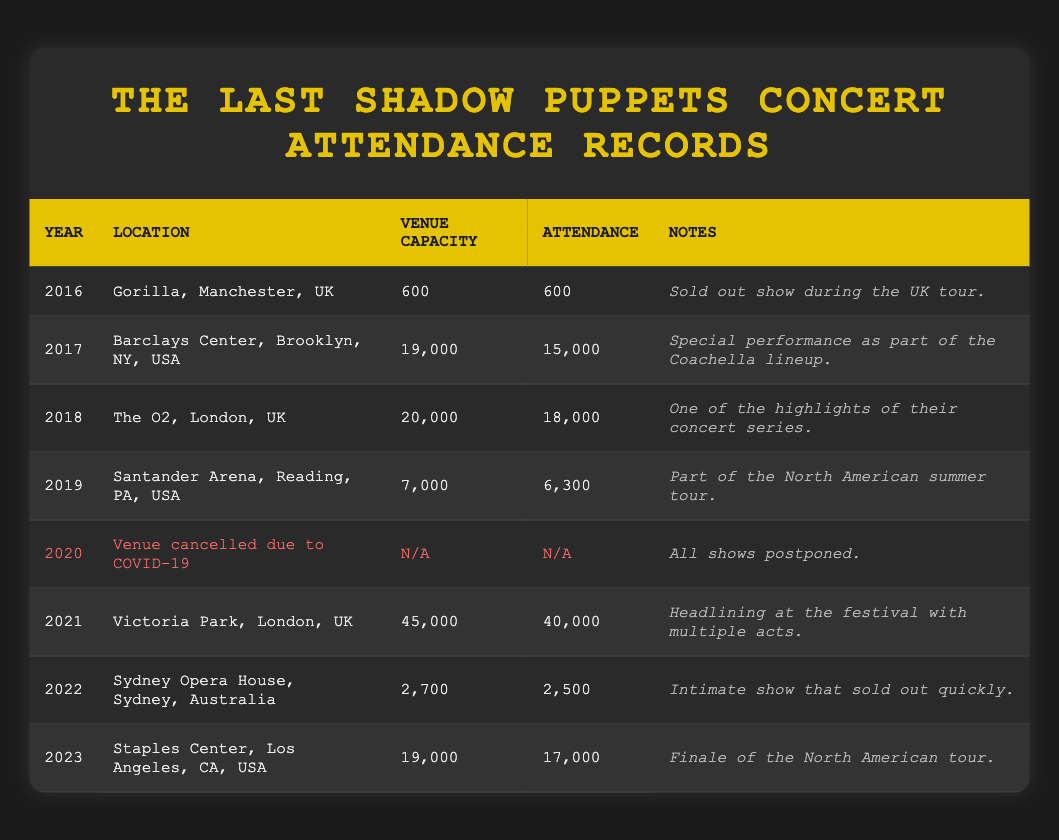What was the attendance at the 2019 concert? The table shows that the attendance for the 2019 concert at Santander Arena in Reading, PA, USA was 6,300.
Answer: 6,300 Which concert had the highest venue capacity? The table shows that the concert at Victoria Park in London, UK in 2021 had the highest venue capacity of 45,000.
Answer: 45,000 Was there a concert in 2020? The table indicates that there was a venue cancelled in 2020 due to COVID-19, meaning there were no concerts held that year.
Answer: No What is the difference in attendance between the 2021 and 2022 concerts? The attendance for the 2021 concert was 40,000 and for the 2022 concert it was 2,500. The difference is 40,000 - 2,500 = 37,500.
Answer: 37,500 Which year saw a concert with an attendance above 15,000? The years 2017, 2018, and 2021 all had attendance figures above 15,000, with 2017 at 15,000, 2018 at 18,000, and 2021 at 40,000.
Answer: 2017, 2018, 2021 What was the average attendance for concerts held in 2016, 2017, and 2018? The attendance figures for those years are 600 (2016), 15,000 (2017), and 18,000 (2018). The average can be calculated as (600 + 15,000 + 18,000) / 3 = 11,200.
Answer: 11,200 How many concerts were held in total from 2016 to 2023? The table lists concerts from 2016 to 2023, totaling 8 entries (including the cancelled concert in 2020).
Answer: 8 What percentage of venue capacity was filled at The O2 concert in 2018? The venue capacity for The O2 was 20,000, and attendance was 18,000. The percentage filled can be calculated as (18,000 / 20,000) * 100 = 90%.
Answer: 90% Which concert had the lowest attendance? The concert at the Sydney Opera House in 2022 had the lowest attendance at 2,500.
Answer: 2,500 In which year was the concert at Barclays Center held and how many people attended? The concert at Barclays Center in Brooklyn, NY, USA was held in 2017 with an attendance of 15,000.
Answer: 2017, 15,000 Was the concert at Gorilla in Manchester sold out? The notes for the 2016 concert at Gorilla, Manchester, UK, state that it was a sold-out show.
Answer: Yes 